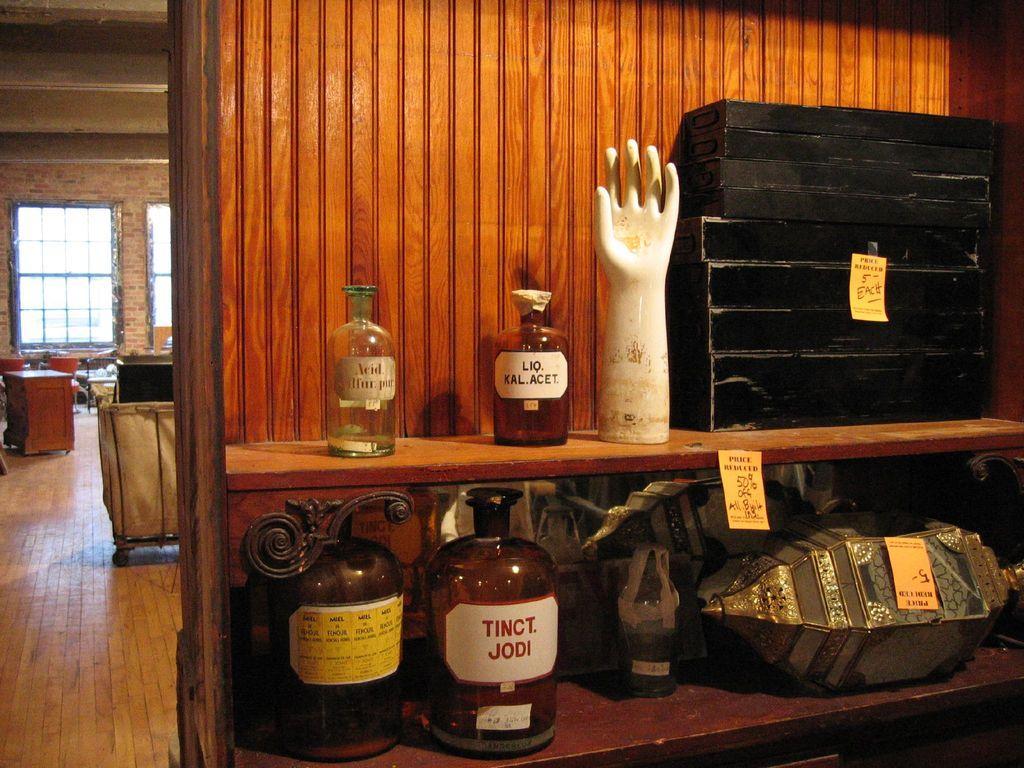Describe this image in one or two sentences. There is a wooden wall with racks. On the racks there are bottles, statue of a hand, trunk box and some other items. In the background there is a window and tables. 